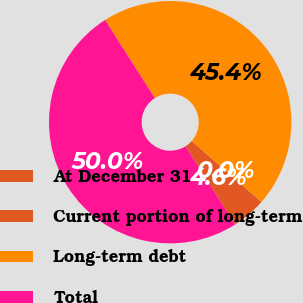Convert chart to OTSL. <chart><loc_0><loc_0><loc_500><loc_500><pie_chart><fcel>At December 31<fcel>Current portion of long-term<fcel>Long-term debt<fcel>Total<nl><fcel>4.56%<fcel>0.02%<fcel>45.44%<fcel>49.98%<nl></chart> 